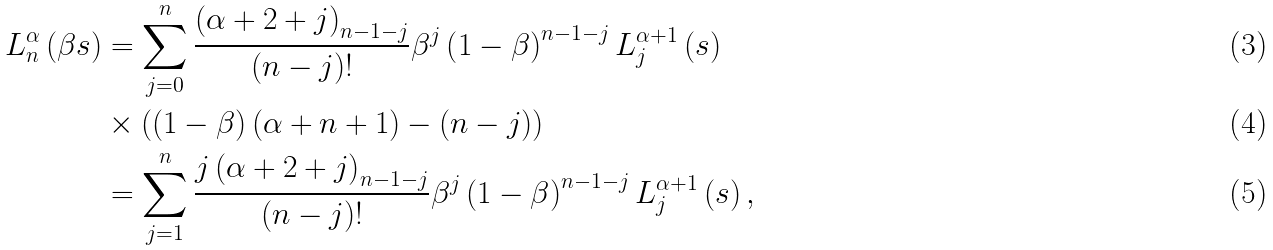Convert formula to latex. <formula><loc_0><loc_0><loc_500><loc_500>L _ { n } ^ { \alpha } \left ( \beta s \right ) & = \sum _ { j = 0 } ^ { n } \frac { \left ( \alpha + 2 + j \right ) _ { n - 1 - j } } { \left ( n - j \right ) ! } \beta ^ { j } \left ( 1 - \beta \right ) ^ { n - 1 - j } L _ { j } ^ { \alpha + 1 } \left ( s \right ) \\ & \times \left ( \left ( 1 - \beta \right ) \left ( \alpha + n + 1 \right ) - ( n - j ) \right ) \\ & = \sum _ { j = 1 } ^ { n } \frac { j \left ( \alpha + 2 + j \right ) _ { n - 1 - j } } { \left ( n - j \right ) ! } \beta ^ { j } \left ( 1 - \beta \right ) ^ { n - 1 - j } L _ { j } ^ { \alpha + 1 } \left ( s \right ) ,</formula> 